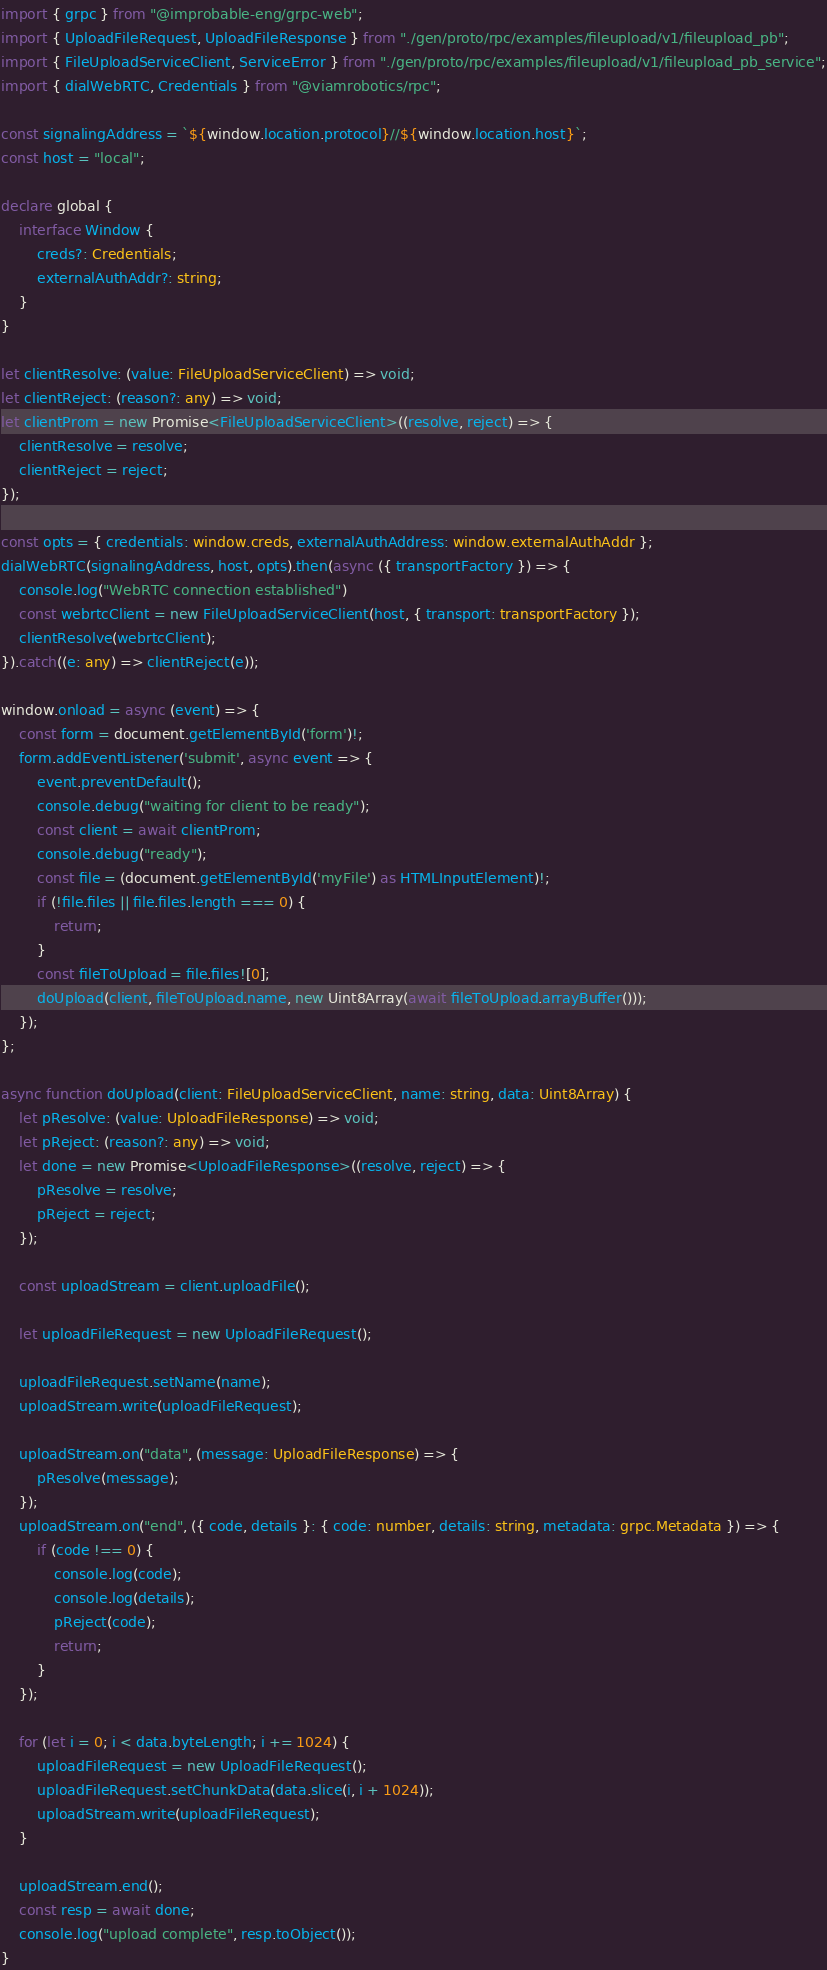Convert code to text. <code><loc_0><loc_0><loc_500><loc_500><_TypeScript_>import { grpc } from "@improbable-eng/grpc-web";
import { UploadFileRequest, UploadFileResponse } from "./gen/proto/rpc/examples/fileupload/v1/fileupload_pb";
import { FileUploadServiceClient, ServiceError } from "./gen/proto/rpc/examples/fileupload/v1/fileupload_pb_service";
import { dialWebRTC, Credentials } from "@viamrobotics/rpc";

const signalingAddress = `${window.location.protocol}//${window.location.host}`;
const host = "local";

declare global {
	interface Window {
		creds?: Credentials;
		externalAuthAddr?: string;
	}
}

let clientResolve: (value: FileUploadServiceClient) => void;
let clientReject: (reason?: any) => void;
let clientProm = new Promise<FileUploadServiceClient>((resolve, reject) => {
	clientResolve = resolve;
	clientReject = reject;
});

const opts = { credentials: window.creds, externalAuthAddress: window.externalAuthAddr };
dialWebRTC(signalingAddress, host, opts).then(async ({ transportFactory }) => {
	console.log("WebRTC connection established")
	const webrtcClient = new FileUploadServiceClient(host, { transport: transportFactory });
	clientResolve(webrtcClient);
}).catch((e: any) => clientReject(e));

window.onload = async (event) => {
	const form = document.getElementById('form')!;
	form.addEventListener('submit', async event => {
		event.preventDefault();
		console.debug("waiting for client to be ready");
		const client = await clientProm;
		console.debug("ready");
		const file = (document.getElementById('myFile') as HTMLInputElement)!;
		if (!file.files || file.files.length === 0) {
			return;
		}
		const fileToUpload = file.files![0];
		doUpload(client, fileToUpload.name, new Uint8Array(await fileToUpload.arrayBuffer()));
	});
};

async function doUpload(client: FileUploadServiceClient, name: string, data: Uint8Array) {
	let pResolve: (value: UploadFileResponse) => void;
	let pReject: (reason?: any) => void;
	let done = new Promise<UploadFileResponse>((resolve, reject) => {
		pResolve = resolve;
		pReject = reject;
	});

	const uploadStream = client.uploadFile();

	let uploadFileRequest = new UploadFileRequest();

	uploadFileRequest.setName(name);
	uploadStream.write(uploadFileRequest);

	uploadStream.on("data", (message: UploadFileResponse) => {
		pResolve(message);
	});
	uploadStream.on("end", ({ code, details }: { code: number, details: string, metadata: grpc.Metadata }) => {
		if (code !== 0) {
			console.log(code);
			console.log(details);
			pReject(code);
			return;
		}
	});

	for (let i = 0; i < data.byteLength; i += 1024) {
		uploadFileRequest = new UploadFileRequest();
		uploadFileRequest.setChunkData(data.slice(i, i + 1024));
		uploadStream.write(uploadFileRequest);
	}

	uploadStream.end();
	const resp = await done;
	console.log("upload complete", resp.toObject());
}
</code> 